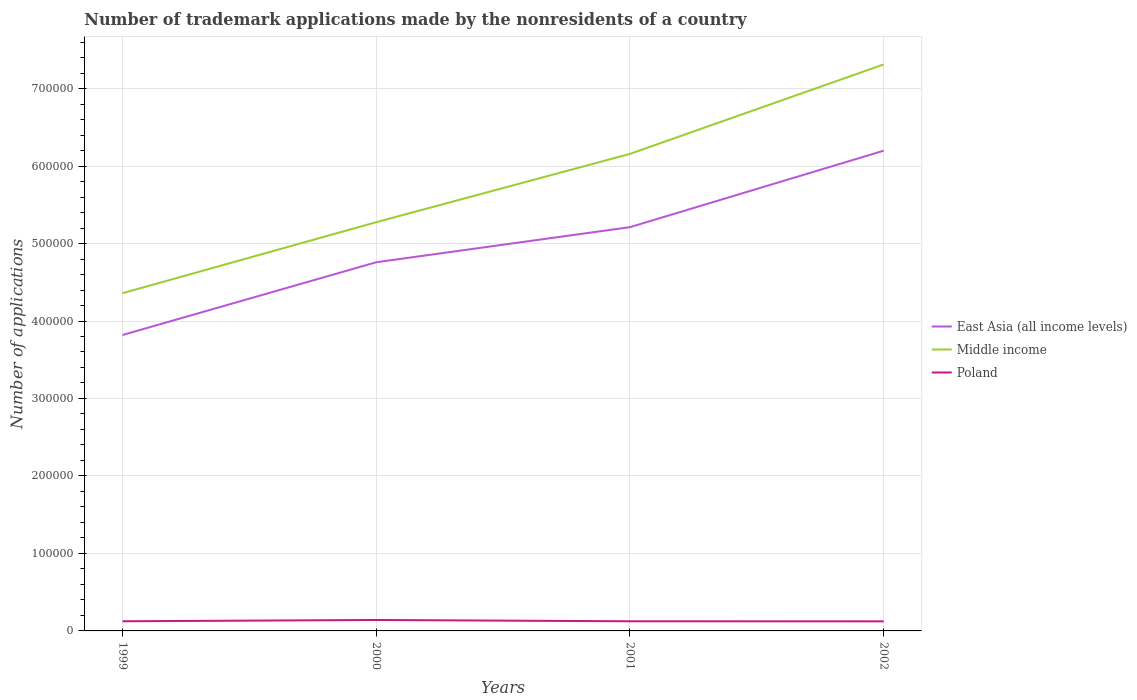Does the line corresponding to East Asia (all income levels) intersect with the line corresponding to Middle income?
Your answer should be very brief. No. Across all years, what is the maximum number of trademark applications made by the nonresidents in Poland?
Provide a short and direct response. 1.24e+04. In which year was the number of trademark applications made by the nonresidents in Poland maximum?
Your answer should be very brief. 2002. What is the total number of trademark applications made by the nonresidents in East Asia (all income levels) in the graph?
Your answer should be very brief. -9.87e+04. What is the difference between the highest and the second highest number of trademark applications made by the nonresidents in Poland?
Your answer should be very brief. 1756. What is the difference between the highest and the lowest number of trademark applications made by the nonresidents in Poland?
Offer a terse response. 1. How many lines are there?
Ensure brevity in your answer.  3. How many years are there in the graph?
Offer a very short reply. 4. How many legend labels are there?
Make the answer very short. 3. What is the title of the graph?
Your answer should be very brief. Number of trademark applications made by the nonresidents of a country. Does "Germany" appear as one of the legend labels in the graph?
Keep it short and to the point. No. What is the label or title of the X-axis?
Your answer should be very brief. Years. What is the label or title of the Y-axis?
Ensure brevity in your answer.  Number of applications. What is the Number of applications in East Asia (all income levels) in 1999?
Give a very brief answer. 3.82e+05. What is the Number of applications of Middle income in 1999?
Make the answer very short. 4.36e+05. What is the Number of applications of Poland in 1999?
Offer a very short reply. 1.25e+04. What is the Number of applications in East Asia (all income levels) in 2000?
Your answer should be compact. 4.76e+05. What is the Number of applications in Middle income in 2000?
Ensure brevity in your answer.  5.28e+05. What is the Number of applications of Poland in 2000?
Keep it short and to the point. 1.41e+04. What is the Number of applications in East Asia (all income levels) in 2001?
Ensure brevity in your answer.  5.21e+05. What is the Number of applications of Middle income in 2001?
Your answer should be compact. 6.16e+05. What is the Number of applications of Poland in 2001?
Make the answer very short. 1.24e+04. What is the Number of applications of East Asia (all income levels) in 2002?
Make the answer very short. 6.20e+05. What is the Number of applications in Middle income in 2002?
Your answer should be very brief. 7.31e+05. What is the Number of applications in Poland in 2002?
Keep it short and to the point. 1.24e+04. Across all years, what is the maximum Number of applications of East Asia (all income levels)?
Offer a terse response. 6.20e+05. Across all years, what is the maximum Number of applications in Middle income?
Your answer should be compact. 7.31e+05. Across all years, what is the maximum Number of applications in Poland?
Your response must be concise. 1.41e+04. Across all years, what is the minimum Number of applications of East Asia (all income levels)?
Your answer should be very brief. 3.82e+05. Across all years, what is the minimum Number of applications in Middle income?
Your response must be concise. 4.36e+05. Across all years, what is the minimum Number of applications of Poland?
Provide a succinct answer. 1.24e+04. What is the total Number of applications in East Asia (all income levels) in the graph?
Your response must be concise. 2.00e+06. What is the total Number of applications of Middle income in the graph?
Keep it short and to the point. 2.31e+06. What is the total Number of applications of Poland in the graph?
Offer a terse response. 5.14e+04. What is the difference between the Number of applications in East Asia (all income levels) in 1999 and that in 2000?
Offer a very short reply. -9.39e+04. What is the difference between the Number of applications of Middle income in 1999 and that in 2000?
Keep it short and to the point. -9.16e+04. What is the difference between the Number of applications of Poland in 1999 and that in 2000?
Make the answer very short. -1644. What is the difference between the Number of applications of East Asia (all income levels) in 1999 and that in 2001?
Ensure brevity in your answer.  -1.39e+05. What is the difference between the Number of applications in Middle income in 1999 and that in 2001?
Offer a terse response. -1.80e+05. What is the difference between the Number of applications in Poland in 1999 and that in 2001?
Offer a very short reply. 33. What is the difference between the Number of applications in East Asia (all income levels) in 1999 and that in 2002?
Provide a short and direct response. -2.38e+05. What is the difference between the Number of applications in Middle income in 1999 and that in 2002?
Your answer should be very brief. -2.95e+05. What is the difference between the Number of applications in Poland in 1999 and that in 2002?
Your response must be concise. 112. What is the difference between the Number of applications of East Asia (all income levels) in 2000 and that in 2001?
Your answer should be very brief. -4.53e+04. What is the difference between the Number of applications of Middle income in 2000 and that in 2001?
Your response must be concise. -8.82e+04. What is the difference between the Number of applications of Poland in 2000 and that in 2001?
Provide a short and direct response. 1677. What is the difference between the Number of applications in East Asia (all income levels) in 2000 and that in 2002?
Keep it short and to the point. -1.44e+05. What is the difference between the Number of applications of Middle income in 2000 and that in 2002?
Keep it short and to the point. -2.04e+05. What is the difference between the Number of applications in Poland in 2000 and that in 2002?
Ensure brevity in your answer.  1756. What is the difference between the Number of applications in East Asia (all income levels) in 2001 and that in 2002?
Give a very brief answer. -9.87e+04. What is the difference between the Number of applications of Middle income in 2001 and that in 2002?
Make the answer very short. -1.15e+05. What is the difference between the Number of applications in Poland in 2001 and that in 2002?
Make the answer very short. 79. What is the difference between the Number of applications in East Asia (all income levels) in 1999 and the Number of applications in Middle income in 2000?
Your answer should be compact. -1.46e+05. What is the difference between the Number of applications of East Asia (all income levels) in 1999 and the Number of applications of Poland in 2000?
Offer a very short reply. 3.68e+05. What is the difference between the Number of applications of Middle income in 1999 and the Number of applications of Poland in 2000?
Offer a terse response. 4.22e+05. What is the difference between the Number of applications of East Asia (all income levels) in 1999 and the Number of applications of Middle income in 2001?
Ensure brevity in your answer.  -2.34e+05. What is the difference between the Number of applications in East Asia (all income levels) in 1999 and the Number of applications in Poland in 2001?
Offer a terse response. 3.69e+05. What is the difference between the Number of applications of Middle income in 1999 and the Number of applications of Poland in 2001?
Provide a short and direct response. 4.23e+05. What is the difference between the Number of applications in East Asia (all income levels) in 1999 and the Number of applications in Middle income in 2002?
Provide a short and direct response. -3.49e+05. What is the difference between the Number of applications of East Asia (all income levels) in 1999 and the Number of applications of Poland in 2002?
Ensure brevity in your answer.  3.70e+05. What is the difference between the Number of applications of Middle income in 1999 and the Number of applications of Poland in 2002?
Ensure brevity in your answer.  4.24e+05. What is the difference between the Number of applications of East Asia (all income levels) in 2000 and the Number of applications of Middle income in 2001?
Your answer should be compact. -1.40e+05. What is the difference between the Number of applications of East Asia (all income levels) in 2000 and the Number of applications of Poland in 2001?
Provide a short and direct response. 4.63e+05. What is the difference between the Number of applications of Middle income in 2000 and the Number of applications of Poland in 2001?
Ensure brevity in your answer.  5.15e+05. What is the difference between the Number of applications of East Asia (all income levels) in 2000 and the Number of applications of Middle income in 2002?
Your response must be concise. -2.55e+05. What is the difference between the Number of applications in East Asia (all income levels) in 2000 and the Number of applications in Poland in 2002?
Give a very brief answer. 4.63e+05. What is the difference between the Number of applications in Middle income in 2000 and the Number of applications in Poland in 2002?
Provide a short and direct response. 5.15e+05. What is the difference between the Number of applications in East Asia (all income levels) in 2001 and the Number of applications in Middle income in 2002?
Make the answer very short. -2.10e+05. What is the difference between the Number of applications in East Asia (all income levels) in 2001 and the Number of applications in Poland in 2002?
Offer a terse response. 5.09e+05. What is the difference between the Number of applications of Middle income in 2001 and the Number of applications of Poland in 2002?
Keep it short and to the point. 6.03e+05. What is the average Number of applications of East Asia (all income levels) per year?
Provide a short and direct response. 5.00e+05. What is the average Number of applications in Middle income per year?
Give a very brief answer. 5.78e+05. What is the average Number of applications in Poland per year?
Your answer should be compact. 1.28e+04. In the year 1999, what is the difference between the Number of applications of East Asia (all income levels) and Number of applications of Middle income?
Give a very brief answer. -5.40e+04. In the year 1999, what is the difference between the Number of applications of East Asia (all income levels) and Number of applications of Poland?
Offer a very short reply. 3.69e+05. In the year 1999, what is the difference between the Number of applications of Middle income and Number of applications of Poland?
Give a very brief answer. 4.23e+05. In the year 2000, what is the difference between the Number of applications of East Asia (all income levels) and Number of applications of Middle income?
Ensure brevity in your answer.  -5.17e+04. In the year 2000, what is the difference between the Number of applications of East Asia (all income levels) and Number of applications of Poland?
Ensure brevity in your answer.  4.62e+05. In the year 2000, what is the difference between the Number of applications of Middle income and Number of applications of Poland?
Your answer should be compact. 5.13e+05. In the year 2001, what is the difference between the Number of applications of East Asia (all income levels) and Number of applications of Middle income?
Ensure brevity in your answer.  -9.46e+04. In the year 2001, what is the difference between the Number of applications in East Asia (all income levels) and Number of applications in Poland?
Keep it short and to the point. 5.09e+05. In the year 2001, what is the difference between the Number of applications in Middle income and Number of applications in Poland?
Make the answer very short. 6.03e+05. In the year 2002, what is the difference between the Number of applications in East Asia (all income levels) and Number of applications in Middle income?
Make the answer very short. -1.11e+05. In the year 2002, what is the difference between the Number of applications of East Asia (all income levels) and Number of applications of Poland?
Provide a succinct answer. 6.07e+05. In the year 2002, what is the difference between the Number of applications in Middle income and Number of applications in Poland?
Your answer should be very brief. 7.19e+05. What is the ratio of the Number of applications of East Asia (all income levels) in 1999 to that in 2000?
Your answer should be very brief. 0.8. What is the ratio of the Number of applications in Middle income in 1999 to that in 2000?
Provide a short and direct response. 0.83. What is the ratio of the Number of applications of Poland in 1999 to that in 2000?
Offer a terse response. 0.88. What is the ratio of the Number of applications in East Asia (all income levels) in 1999 to that in 2001?
Offer a terse response. 0.73. What is the ratio of the Number of applications of Middle income in 1999 to that in 2001?
Provide a short and direct response. 0.71. What is the ratio of the Number of applications in Poland in 1999 to that in 2001?
Give a very brief answer. 1. What is the ratio of the Number of applications of East Asia (all income levels) in 1999 to that in 2002?
Offer a very short reply. 0.62. What is the ratio of the Number of applications in Middle income in 1999 to that in 2002?
Give a very brief answer. 0.6. What is the ratio of the Number of applications of Poland in 1999 to that in 2002?
Provide a short and direct response. 1.01. What is the ratio of the Number of applications of East Asia (all income levels) in 2000 to that in 2001?
Make the answer very short. 0.91. What is the ratio of the Number of applications of Middle income in 2000 to that in 2001?
Offer a terse response. 0.86. What is the ratio of the Number of applications in Poland in 2000 to that in 2001?
Give a very brief answer. 1.13. What is the ratio of the Number of applications of East Asia (all income levels) in 2000 to that in 2002?
Provide a succinct answer. 0.77. What is the ratio of the Number of applications of Middle income in 2000 to that in 2002?
Your answer should be very brief. 0.72. What is the ratio of the Number of applications in Poland in 2000 to that in 2002?
Your answer should be very brief. 1.14. What is the ratio of the Number of applications of East Asia (all income levels) in 2001 to that in 2002?
Offer a very short reply. 0.84. What is the ratio of the Number of applications in Middle income in 2001 to that in 2002?
Offer a terse response. 0.84. What is the ratio of the Number of applications of Poland in 2001 to that in 2002?
Ensure brevity in your answer.  1.01. What is the difference between the highest and the second highest Number of applications of East Asia (all income levels)?
Ensure brevity in your answer.  9.87e+04. What is the difference between the highest and the second highest Number of applications in Middle income?
Your answer should be compact. 1.15e+05. What is the difference between the highest and the second highest Number of applications of Poland?
Your answer should be compact. 1644. What is the difference between the highest and the lowest Number of applications in East Asia (all income levels)?
Your answer should be very brief. 2.38e+05. What is the difference between the highest and the lowest Number of applications of Middle income?
Your answer should be compact. 2.95e+05. What is the difference between the highest and the lowest Number of applications in Poland?
Your answer should be compact. 1756. 